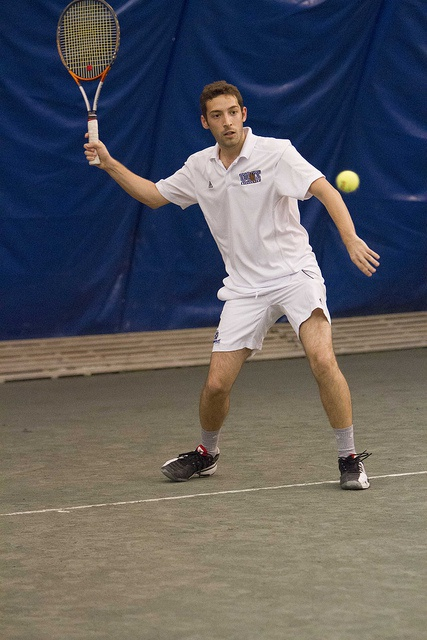Describe the objects in this image and their specific colors. I can see people in navy, lightgray, darkgray, gray, and tan tones, tennis racket in navy, gray, black, and olive tones, and sports ball in navy, khaki, olive, and gray tones in this image. 